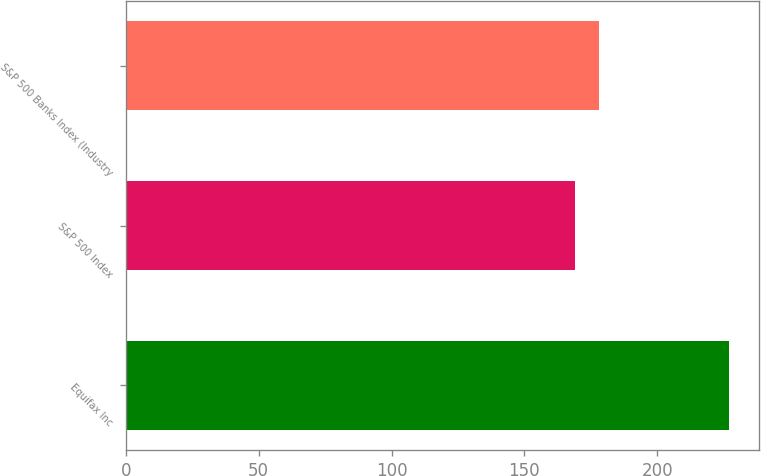Convert chart. <chart><loc_0><loc_0><loc_500><loc_500><bar_chart><fcel>Equifax Inc<fcel>S&P 500 Index<fcel>S&P 500 Banks Index (Industry<nl><fcel>226.9<fcel>169.24<fcel>178.13<nl></chart> 